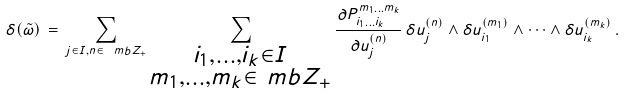Convert formula to latex. <formula><loc_0><loc_0><loc_500><loc_500>\delta ( \tilde { \omega } ) \, = \, \sum _ { j \in I , n \in \ m b Z _ { + } } \sum _ { \substack { i _ { 1 } , \dots , i _ { k } \in I \\ m _ { 1 } , \dots , m _ { k } \in \ m b { Z } _ { + } } } \frac { \partial P ^ { m _ { 1 } \dots m _ { k } } _ { i _ { 1 } \dots i _ { k } } } { \partial u _ { j } ^ { ( n ) } } \, \delta u _ { j } ^ { ( n ) } \wedge \delta u _ { i _ { 1 } } ^ { ( m _ { 1 } ) } \wedge \dots \wedge \delta u _ { i _ { k } } ^ { ( m _ { k } ) } \, .</formula> 